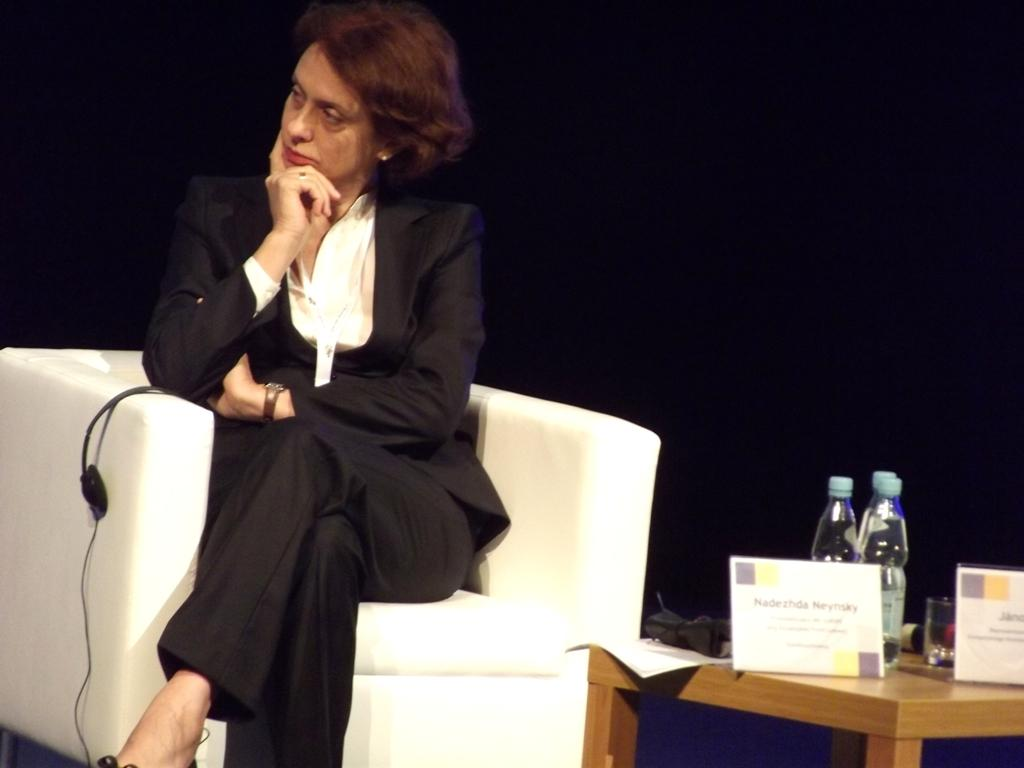Who is present in the image? There is a woman in the image. What is the woman doing in the image? The woman is sitting on a sofa. What is in front of the woman? There is a table in front of the woman. What can be seen on the table? There are water bottles on the table. What type of toad can be seen sitting next to the woman in the image? There is no toad present in the image; only the woman, sofa, table, and water bottles are visible. 